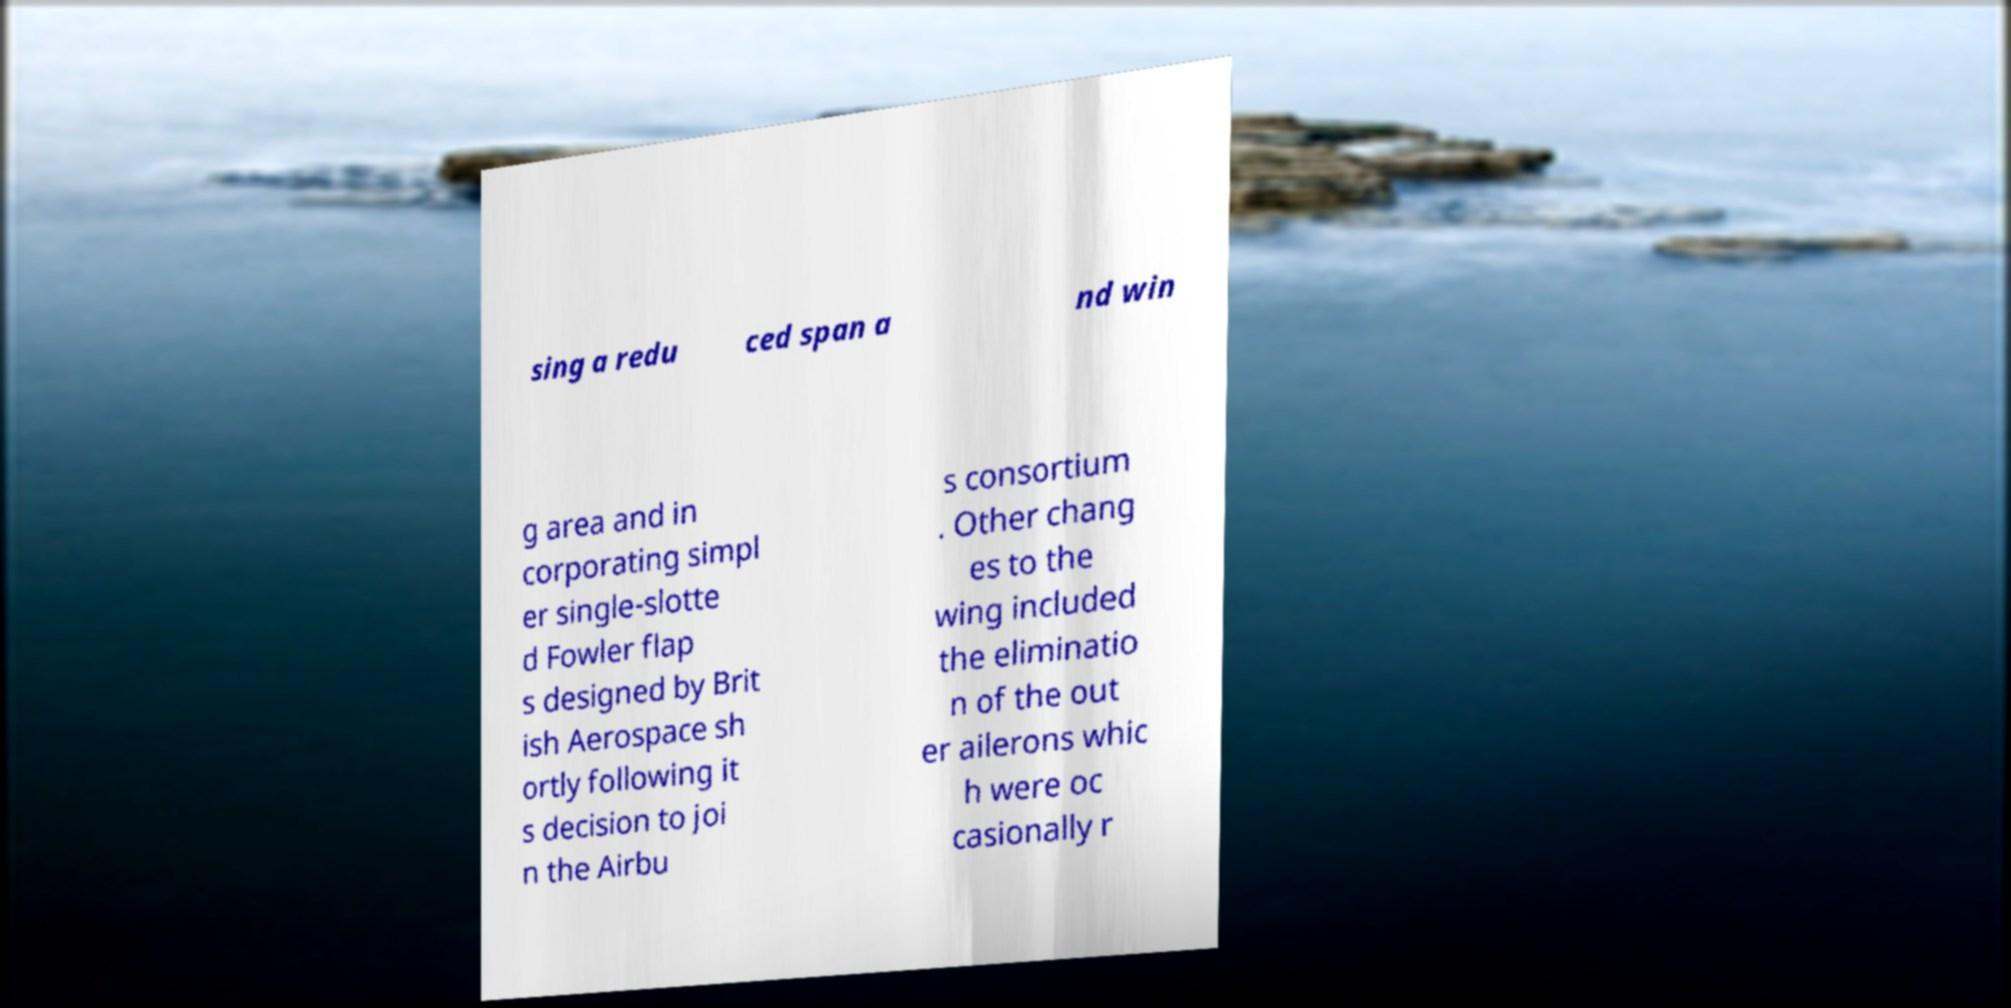There's text embedded in this image that I need extracted. Can you transcribe it verbatim? sing a redu ced span a nd win g area and in corporating simpl er single-slotte d Fowler flap s designed by Brit ish Aerospace sh ortly following it s decision to joi n the Airbu s consortium . Other chang es to the wing included the eliminatio n of the out er ailerons whic h were oc casionally r 